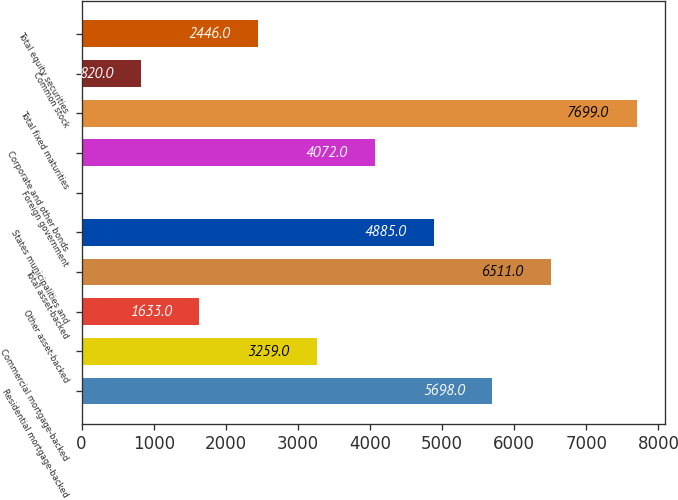<chart> <loc_0><loc_0><loc_500><loc_500><bar_chart><fcel>Residential mortgage-backed<fcel>Commercial mortgage-backed<fcel>Other asset-backed<fcel>Total asset-backed<fcel>States municipalities and<fcel>Foreign government<fcel>Corporate and other bonds<fcel>Total fixed maturities<fcel>Common stock<fcel>Total equity securities<nl><fcel>5698<fcel>3259<fcel>1633<fcel>6511<fcel>4885<fcel>7<fcel>4072<fcel>7699<fcel>820<fcel>2446<nl></chart> 